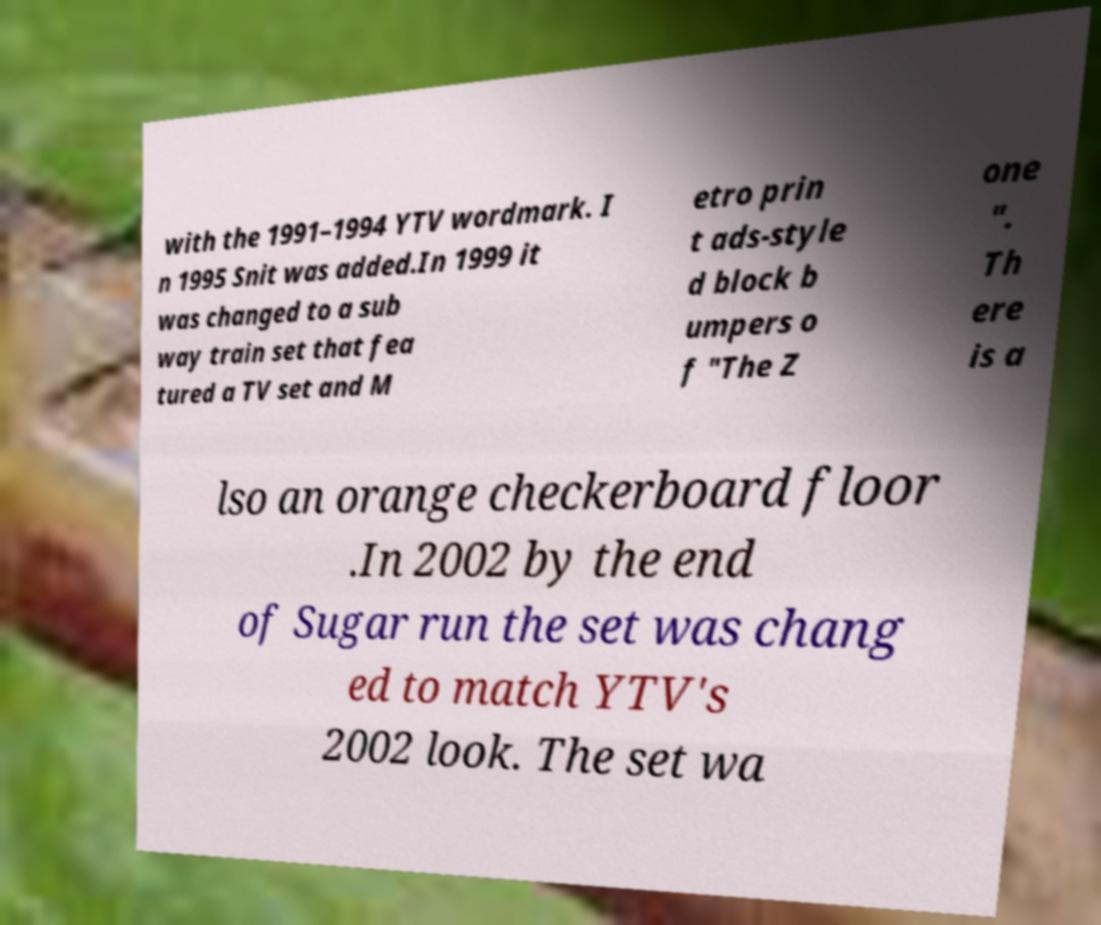Could you extract and type out the text from this image? with the 1991–1994 YTV wordmark. I n 1995 Snit was added.In 1999 it was changed to a sub way train set that fea tured a TV set and M etro prin t ads-style d block b umpers o f "The Z one ". Th ere is a lso an orange checkerboard floor .In 2002 by the end of Sugar run the set was chang ed to match YTV's 2002 look. The set wa 